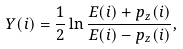Convert formula to latex. <formula><loc_0><loc_0><loc_500><loc_500>Y ( i ) = \frac { 1 } { 2 } \ln \frac { E ( i ) + p _ { z } ( i ) } { E ( i ) - p _ { z } ( i ) } ,</formula> 